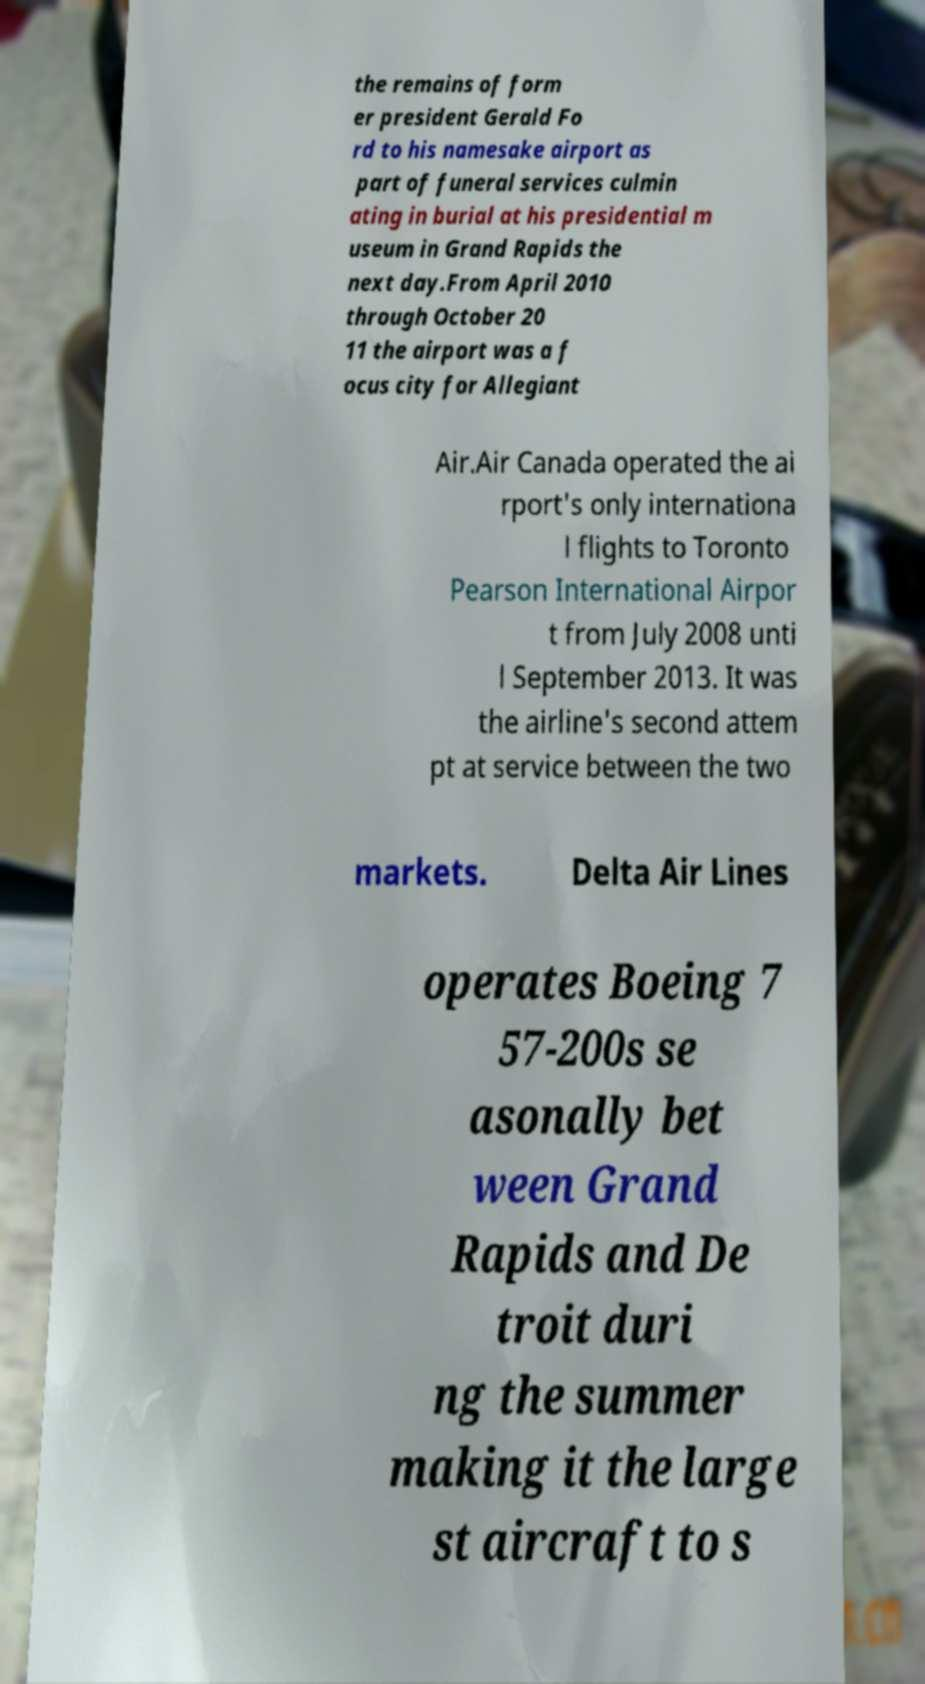For documentation purposes, I need the text within this image transcribed. Could you provide that? the remains of form er president Gerald Fo rd to his namesake airport as part of funeral services culmin ating in burial at his presidential m useum in Grand Rapids the next day.From April 2010 through October 20 11 the airport was a f ocus city for Allegiant Air.Air Canada operated the ai rport's only internationa l flights to Toronto Pearson International Airpor t from July 2008 unti l September 2013. It was the airline's second attem pt at service between the two markets. Delta Air Lines operates Boeing 7 57-200s se asonally bet ween Grand Rapids and De troit duri ng the summer making it the large st aircraft to s 